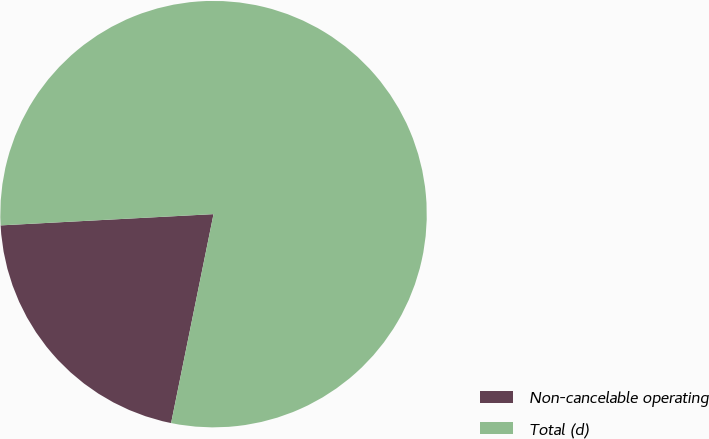Convert chart. <chart><loc_0><loc_0><loc_500><loc_500><pie_chart><fcel>Non-cancelable operating<fcel>Total (d)<nl><fcel>20.97%<fcel>79.03%<nl></chart> 